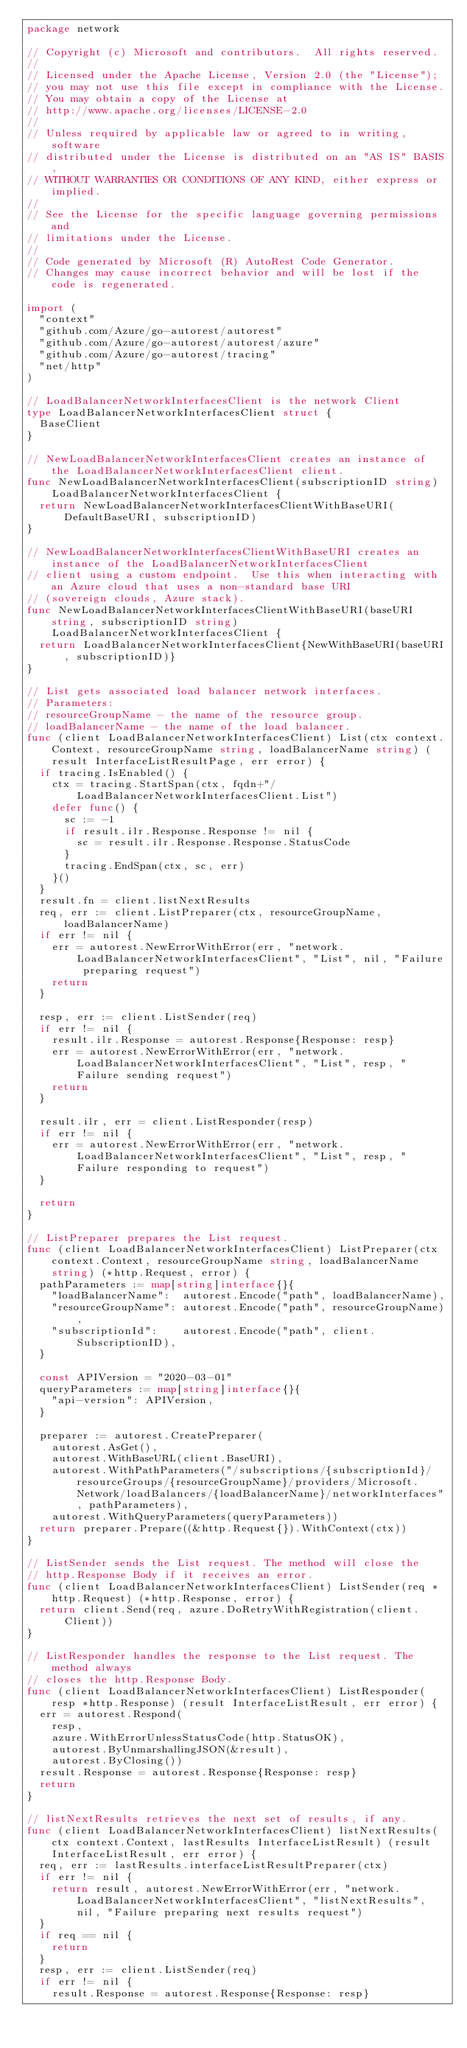<code> <loc_0><loc_0><loc_500><loc_500><_Go_>package network

// Copyright (c) Microsoft and contributors.  All rights reserved.
//
// Licensed under the Apache License, Version 2.0 (the "License");
// you may not use this file except in compliance with the License.
// You may obtain a copy of the License at
// http://www.apache.org/licenses/LICENSE-2.0
//
// Unless required by applicable law or agreed to in writing, software
// distributed under the License is distributed on an "AS IS" BASIS,
// WITHOUT WARRANTIES OR CONDITIONS OF ANY KIND, either express or implied.
//
// See the License for the specific language governing permissions and
// limitations under the License.
//
// Code generated by Microsoft (R) AutoRest Code Generator.
// Changes may cause incorrect behavior and will be lost if the code is regenerated.

import (
	"context"
	"github.com/Azure/go-autorest/autorest"
	"github.com/Azure/go-autorest/autorest/azure"
	"github.com/Azure/go-autorest/tracing"
	"net/http"
)

// LoadBalancerNetworkInterfacesClient is the network Client
type LoadBalancerNetworkInterfacesClient struct {
	BaseClient
}

// NewLoadBalancerNetworkInterfacesClient creates an instance of the LoadBalancerNetworkInterfacesClient client.
func NewLoadBalancerNetworkInterfacesClient(subscriptionID string) LoadBalancerNetworkInterfacesClient {
	return NewLoadBalancerNetworkInterfacesClientWithBaseURI(DefaultBaseURI, subscriptionID)
}

// NewLoadBalancerNetworkInterfacesClientWithBaseURI creates an instance of the LoadBalancerNetworkInterfacesClient
// client using a custom endpoint.  Use this when interacting with an Azure cloud that uses a non-standard base URI
// (sovereign clouds, Azure stack).
func NewLoadBalancerNetworkInterfacesClientWithBaseURI(baseURI string, subscriptionID string) LoadBalancerNetworkInterfacesClient {
	return LoadBalancerNetworkInterfacesClient{NewWithBaseURI(baseURI, subscriptionID)}
}

// List gets associated load balancer network interfaces.
// Parameters:
// resourceGroupName - the name of the resource group.
// loadBalancerName - the name of the load balancer.
func (client LoadBalancerNetworkInterfacesClient) List(ctx context.Context, resourceGroupName string, loadBalancerName string) (result InterfaceListResultPage, err error) {
	if tracing.IsEnabled() {
		ctx = tracing.StartSpan(ctx, fqdn+"/LoadBalancerNetworkInterfacesClient.List")
		defer func() {
			sc := -1
			if result.ilr.Response.Response != nil {
				sc = result.ilr.Response.Response.StatusCode
			}
			tracing.EndSpan(ctx, sc, err)
		}()
	}
	result.fn = client.listNextResults
	req, err := client.ListPreparer(ctx, resourceGroupName, loadBalancerName)
	if err != nil {
		err = autorest.NewErrorWithError(err, "network.LoadBalancerNetworkInterfacesClient", "List", nil, "Failure preparing request")
		return
	}

	resp, err := client.ListSender(req)
	if err != nil {
		result.ilr.Response = autorest.Response{Response: resp}
		err = autorest.NewErrorWithError(err, "network.LoadBalancerNetworkInterfacesClient", "List", resp, "Failure sending request")
		return
	}

	result.ilr, err = client.ListResponder(resp)
	if err != nil {
		err = autorest.NewErrorWithError(err, "network.LoadBalancerNetworkInterfacesClient", "List", resp, "Failure responding to request")
	}

	return
}

// ListPreparer prepares the List request.
func (client LoadBalancerNetworkInterfacesClient) ListPreparer(ctx context.Context, resourceGroupName string, loadBalancerName string) (*http.Request, error) {
	pathParameters := map[string]interface{}{
		"loadBalancerName":  autorest.Encode("path", loadBalancerName),
		"resourceGroupName": autorest.Encode("path", resourceGroupName),
		"subscriptionId":    autorest.Encode("path", client.SubscriptionID),
	}

	const APIVersion = "2020-03-01"
	queryParameters := map[string]interface{}{
		"api-version": APIVersion,
	}

	preparer := autorest.CreatePreparer(
		autorest.AsGet(),
		autorest.WithBaseURL(client.BaseURI),
		autorest.WithPathParameters("/subscriptions/{subscriptionId}/resourceGroups/{resourceGroupName}/providers/Microsoft.Network/loadBalancers/{loadBalancerName}/networkInterfaces", pathParameters),
		autorest.WithQueryParameters(queryParameters))
	return preparer.Prepare((&http.Request{}).WithContext(ctx))
}

// ListSender sends the List request. The method will close the
// http.Response Body if it receives an error.
func (client LoadBalancerNetworkInterfacesClient) ListSender(req *http.Request) (*http.Response, error) {
	return client.Send(req, azure.DoRetryWithRegistration(client.Client))
}

// ListResponder handles the response to the List request. The method always
// closes the http.Response Body.
func (client LoadBalancerNetworkInterfacesClient) ListResponder(resp *http.Response) (result InterfaceListResult, err error) {
	err = autorest.Respond(
		resp,
		azure.WithErrorUnlessStatusCode(http.StatusOK),
		autorest.ByUnmarshallingJSON(&result),
		autorest.ByClosing())
	result.Response = autorest.Response{Response: resp}
	return
}

// listNextResults retrieves the next set of results, if any.
func (client LoadBalancerNetworkInterfacesClient) listNextResults(ctx context.Context, lastResults InterfaceListResult) (result InterfaceListResult, err error) {
	req, err := lastResults.interfaceListResultPreparer(ctx)
	if err != nil {
		return result, autorest.NewErrorWithError(err, "network.LoadBalancerNetworkInterfacesClient", "listNextResults", nil, "Failure preparing next results request")
	}
	if req == nil {
		return
	}
	resp, err := client.ListSender(req)
	if err != nil {
		result.Response = autorest.Response{Response: resp}</code> 